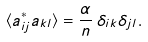<formula> <loc_0><loc_0><loc_500><loc_500>\langle a ^ { * } _ { i j } a _ { k l } \rangle = \frac { \alpha } { n } \, \delta _ { i k } \delta _ { j l } .</formula> 